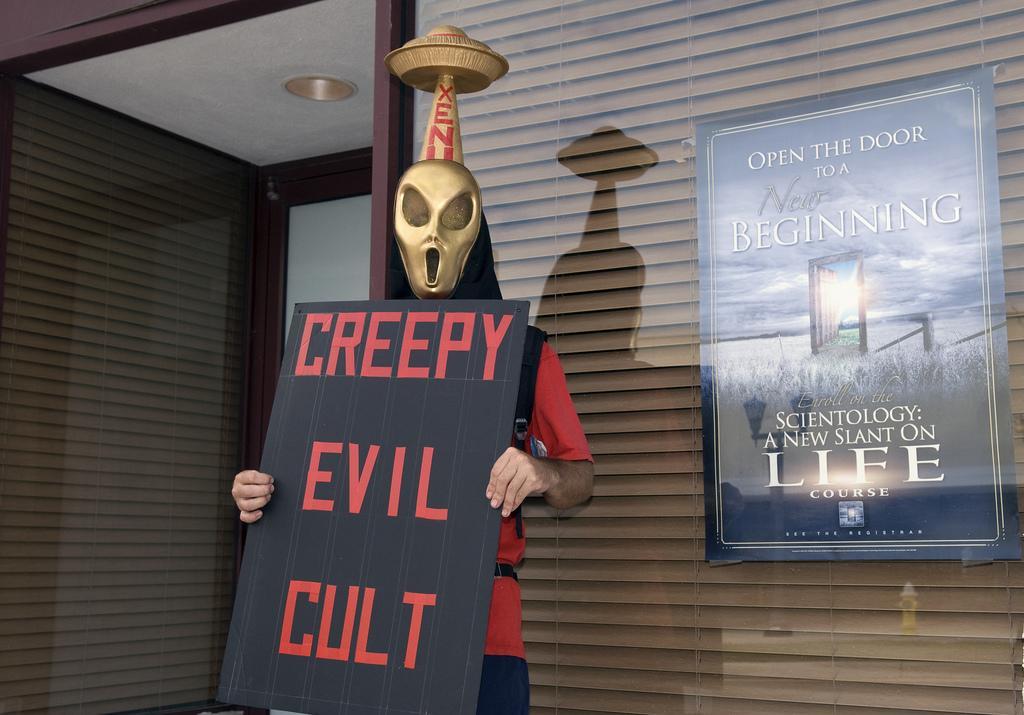Describe this image in one or two sentences. In this image I can see the person with the mask and the person is holding the board. In the background I can see the poster attached to the glass wall and I can also see the glass door. 